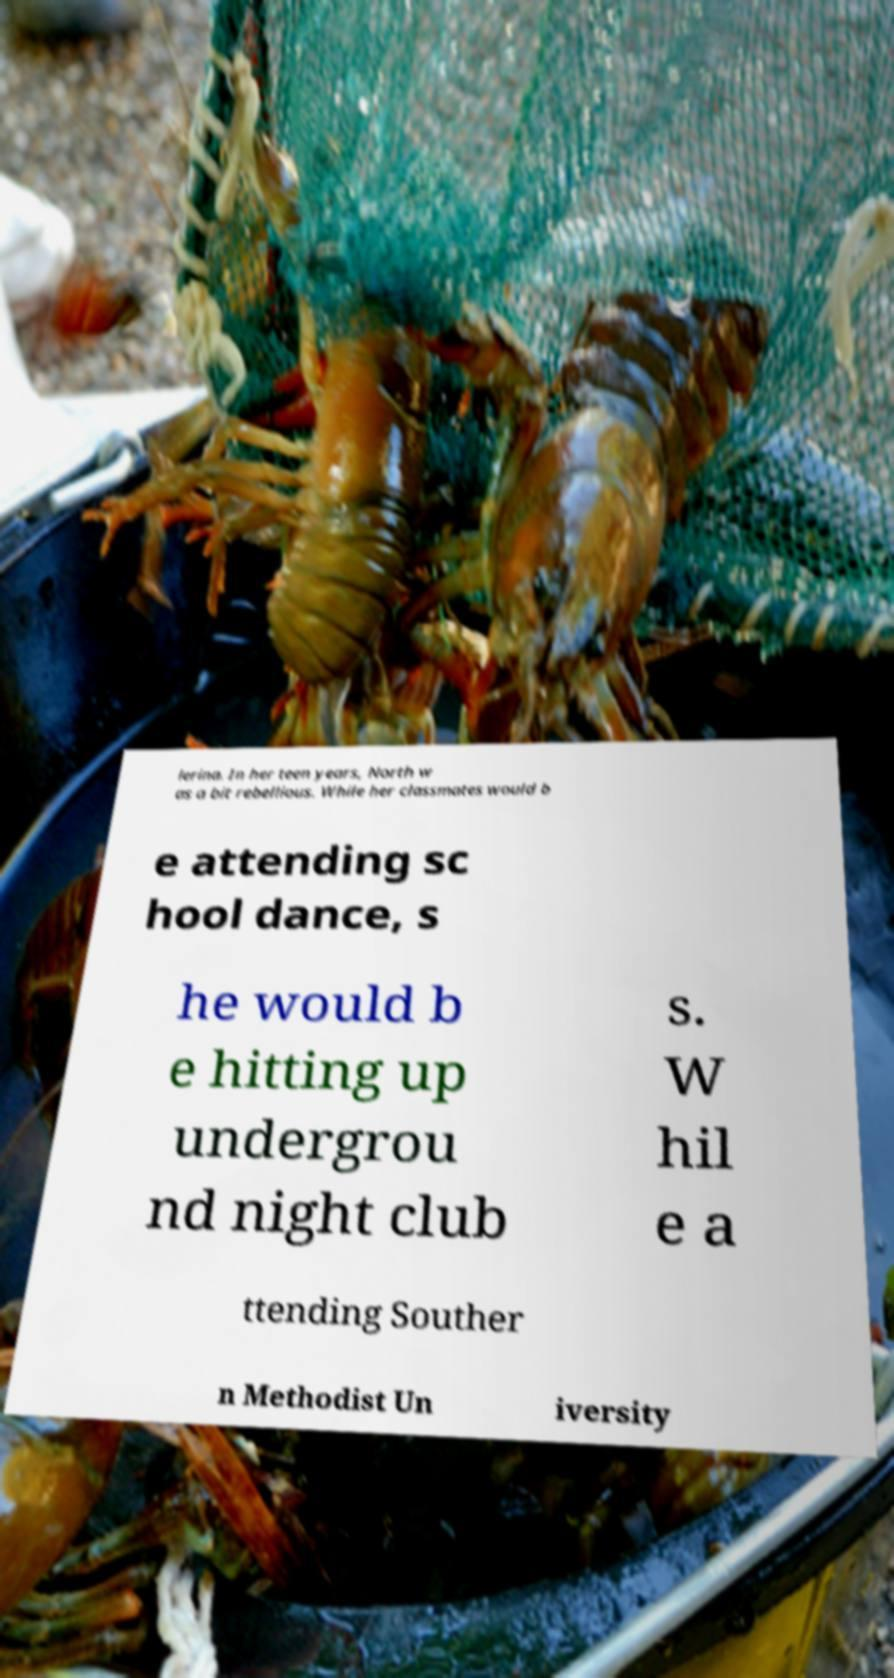Please read and relay the text visible in this image. What does it say? lerina. In her teen years, North w as a bit rebellious. While her classmates would b e attending sc hool dance, s he would b e hitting up undergrou nd night club s. W hil e a ttending Souther n Methodist Un iversity 